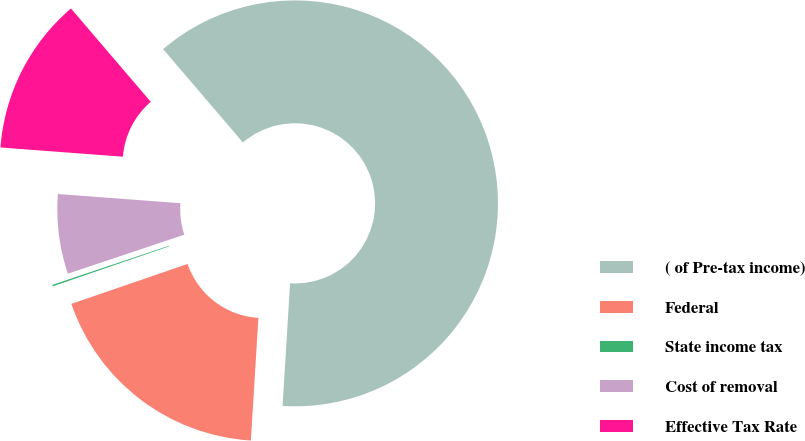<chart> <loc_0><loc_0><loc_500><loc_500><pie_chart><fcel>( of Pre-tax income)<fcel>Federal<fcel>State income tax<fcel>Cost of removal<fcel>Effective Tax Rate<nl><fcel>62.24%<fcel>18.76%<fcel>0.12%<fcel>6.34%<fcel>12.55%<nl></chart> 